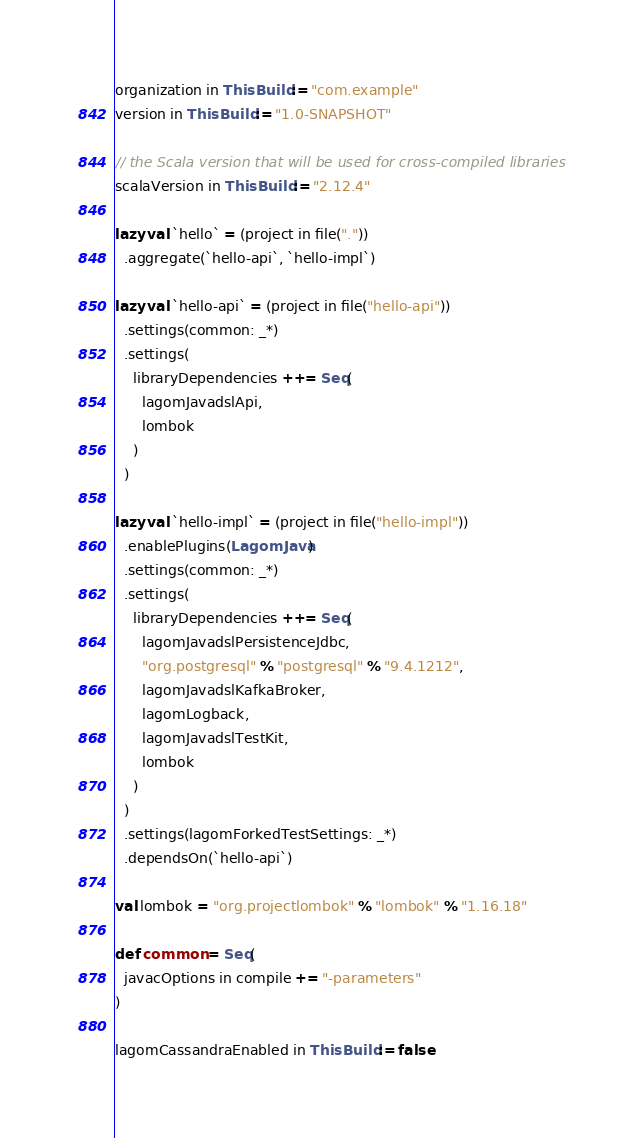<code> <loc_0><loc_0><loc_500><loc_500><_Scala_>organization in ThisBuild := "com.example"
version in ThisBuild := "1.0-SNAPSHOT"

// the Scala version that will be used for cross-compiled libraries
scalaVersion in ThisBuild := "2.12.4"

lazy val `hello` = (project in file("."))
  .aggregate(`hello-api`, `hello-impl`)

lazy val `hello-api` = (project in file("hello-api"))
  .settings(common: _*)
  .settings(
    libraryDependencies ++= Seq(
      lagomJavadslApi,
      lombok
    )
  )

lazy val `hello-impl` = (project in file("hello-impl"))
  .enablePlugins(LagomJava)
  .settings(common: _*)
  .settings(
    libraryDependencies ++= Seq(
      lagomJavadslPersistenceJdbc,
      "org.postgresql" % "postgresql" % "9.4.1212",
      lagomJavadslKafkaBroker,
      lagomLogback,
      lagomJavadslTestKit,
      lombok
    )
  )
  .settings(lagomForkedTestSettings: _*)
  .dependsOn(`hello-api`)

val lombok = "org.projectlombok" % "lombok" % "1.16.18"

def common = Seq(
  javacOptions in compile += "-parameters"
)

lagomCassandraEnabled in ThisBuild := false
</code> 